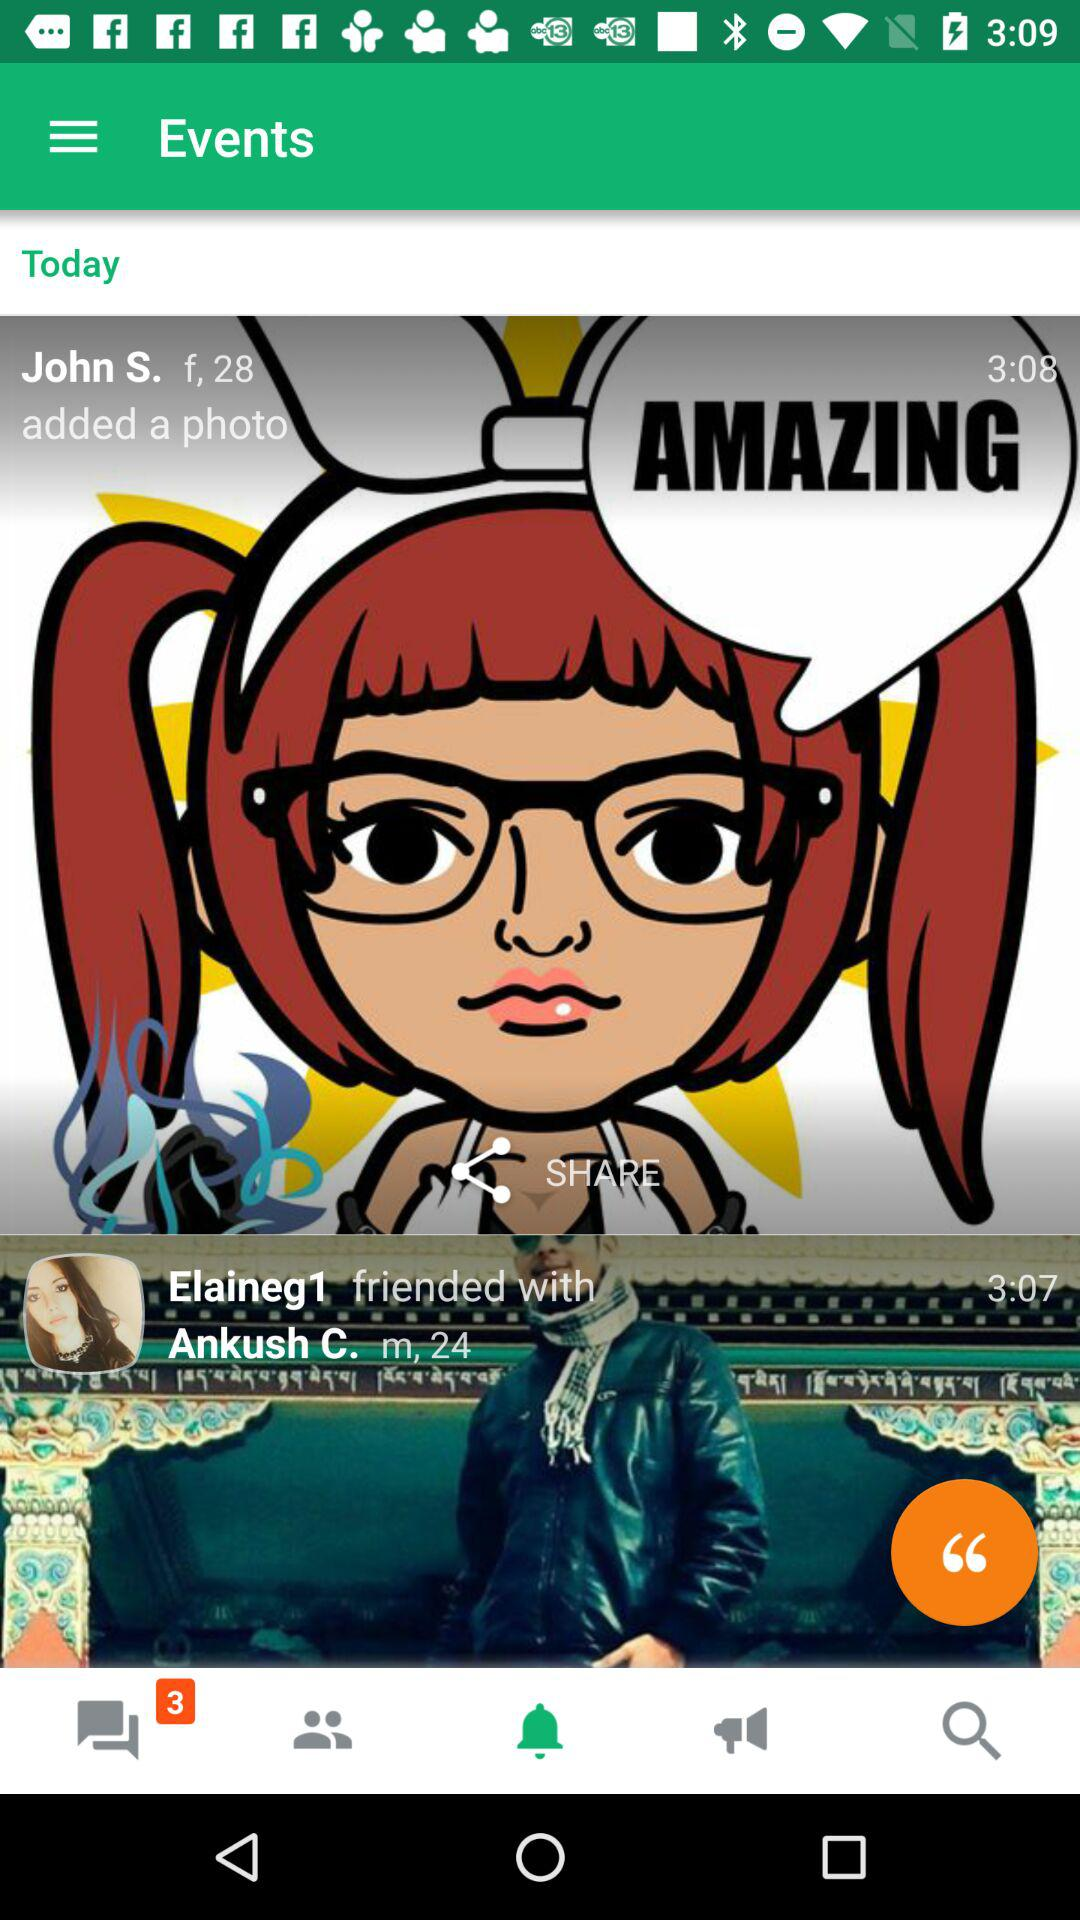How many photos are in the feed?
Answer the question using a single word or phrase. 2 